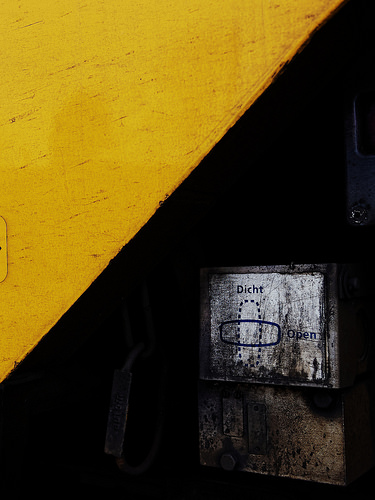<image>
Is the yellow wall behind the sign? No. The yellow wall is not behind the sign. From this viewpoint, the yellow wall appears to be positioned elsewhere in the scene. 